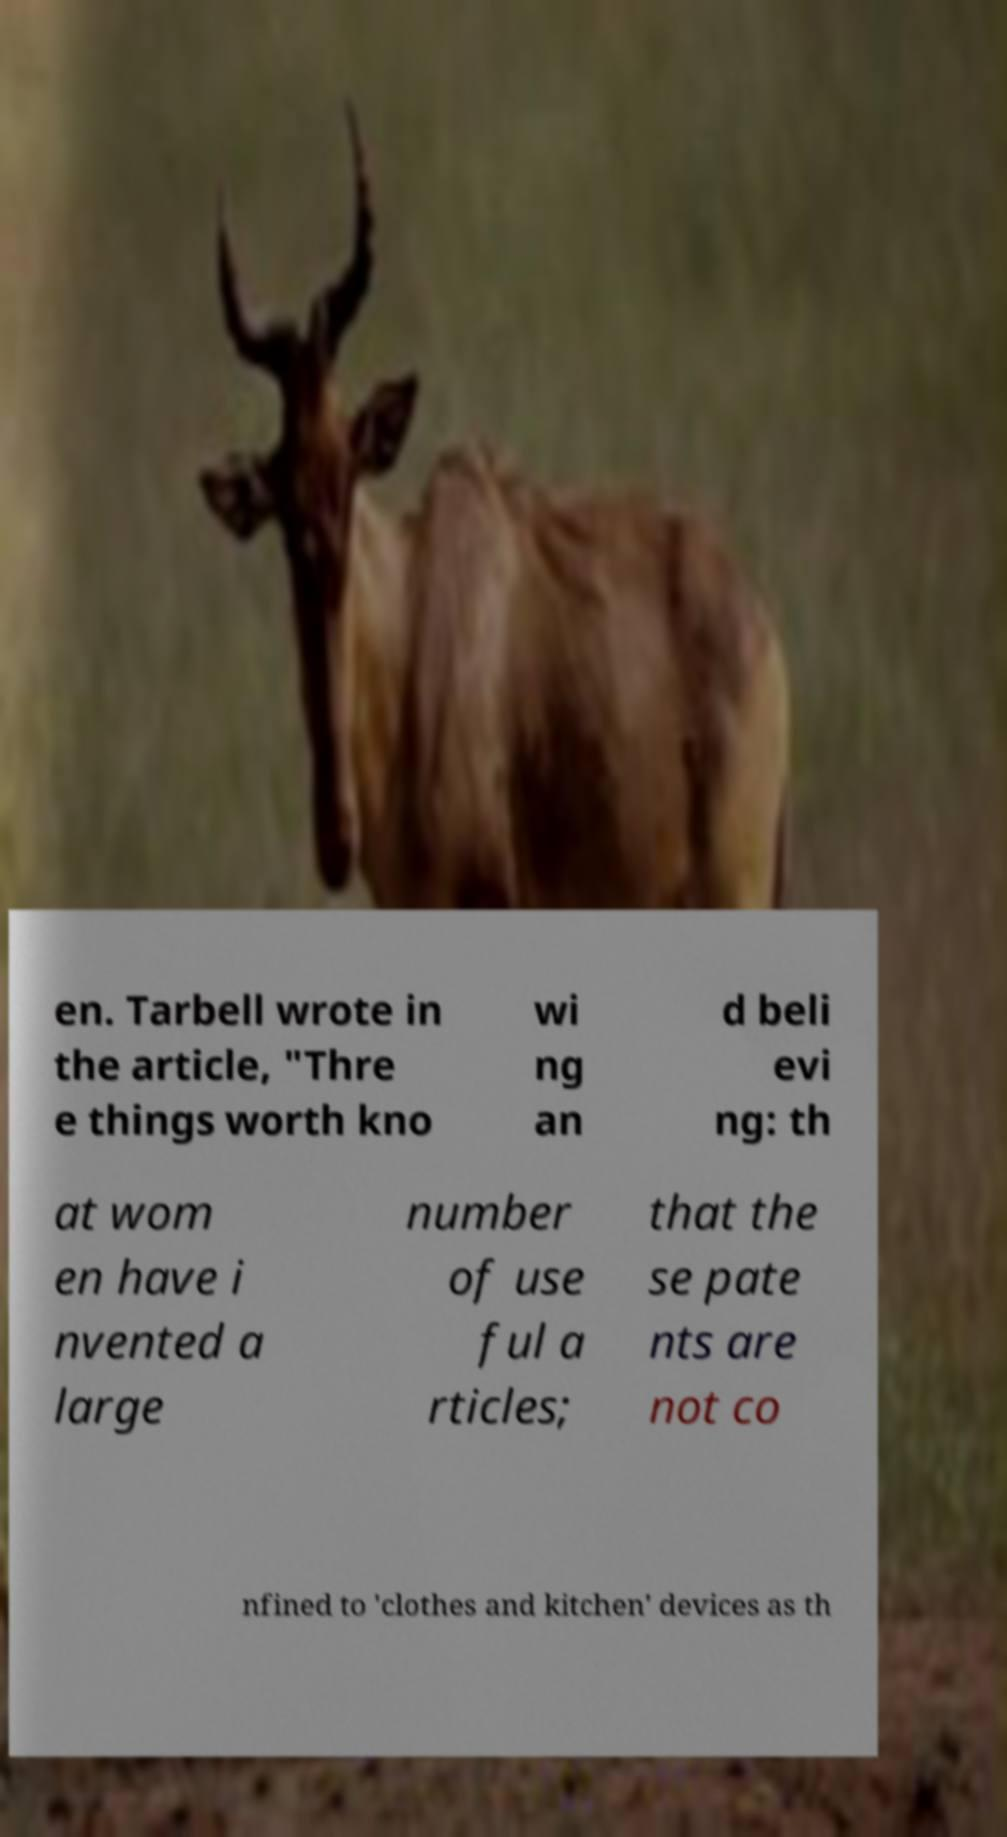What messages or text are displayed in this image? I need them in a readable, typed format. en. Tarbell wrote in the article, "Thre e things worth kno wi ng an d beli evi ng: th at wom en have i nvented a large number of use ful a rticles; that the se pate nts are not co nfined to 'clothes and kitchen' devices as th 